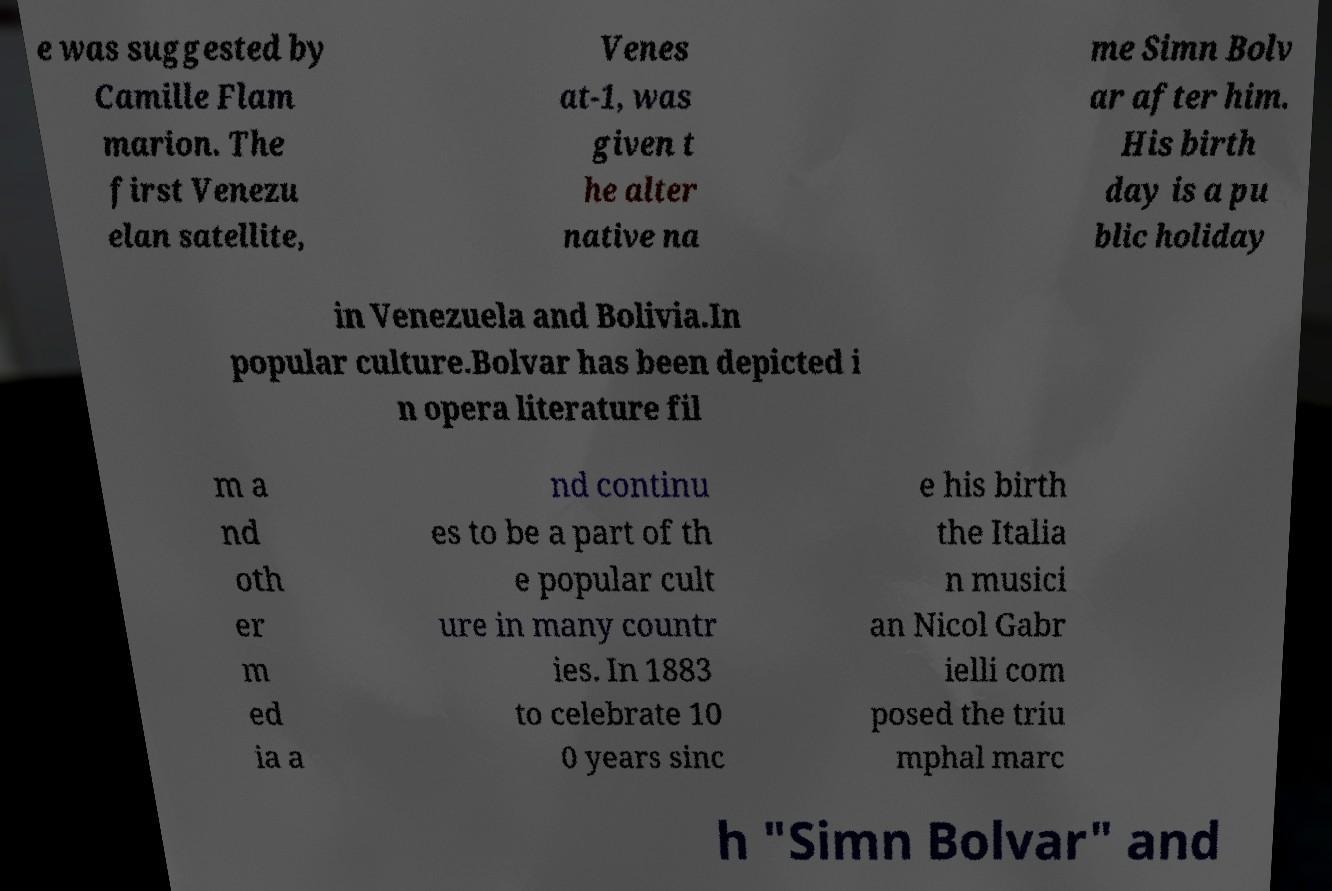Can you read and provide the text displayed in the image?This photo seems to have some interesting text. Can you extract and type it out for me? e was suggested by Camille Flam marion. The first Venezu elan satellite, Venes at-1, was given t he alter native na me Simn Bolv ar after him. His birth day is a pu blic holiday in Venezuela and Bolivia.In popular culture.Bolvar has been depicted i n opera literature fil m a nd oth er m ed ia a nd continu es to be a part of th e popular cult ure in many countr ies. In 1883 to celebrate 10 0 years sinc e his birth the Italia n musici an Nicol Gabr ielli com posed the triu mphal marc h "Simn Bolvar" and 